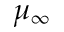Convert formula to latex. <formula><loc_0><loc_0><loc_500><loc_500>\mu _ { \infty }</formula> 